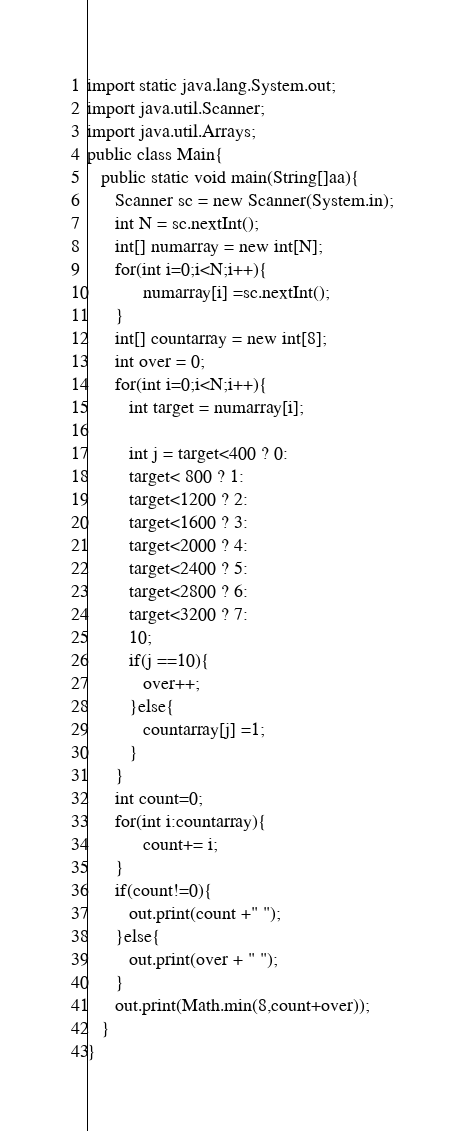Convert code to text. <code><loc_0><loc_0><loc_500><loc_500><_Java_>import static java.lang.System.out;
import java.util.Scanner;
import java.util.Arrays;
public class Main{
   public static void main(String[]aa){
      Scanner sc = new Scanner(System.in); 
      int N = sc.nextInt();
      int[] numarray = new int[N];
      for(int i=0;i<N;i++){
            numarray[i] =sc.nextInt();
      }
      int[] countarray = new int[8];
      int over = 0;
      for(int i=0;i<N;i++){
         int target = numarray[i];
         
         int j = target<400 ? 0:
         target< 800 ? 1:
         target<1200 ? 2:
         target<1600 ? 3:
         target<2000 ? 4:
         target<2400 ? 5:
         target<2800 ? 6:
         target<3200 ? 7:
         10;
         if(j ==10){
            over++;
         }else{
            countarray[j] =1;
         }
      }
      int count=0;
      for(int i:countarray){
            count+= i;
      }
      if(count!=0){
         out.print(count +" ");
      }else{
         out.print(over + " ");
      }
      out.print(Math.min(8,count+over));
   }
}</code> 